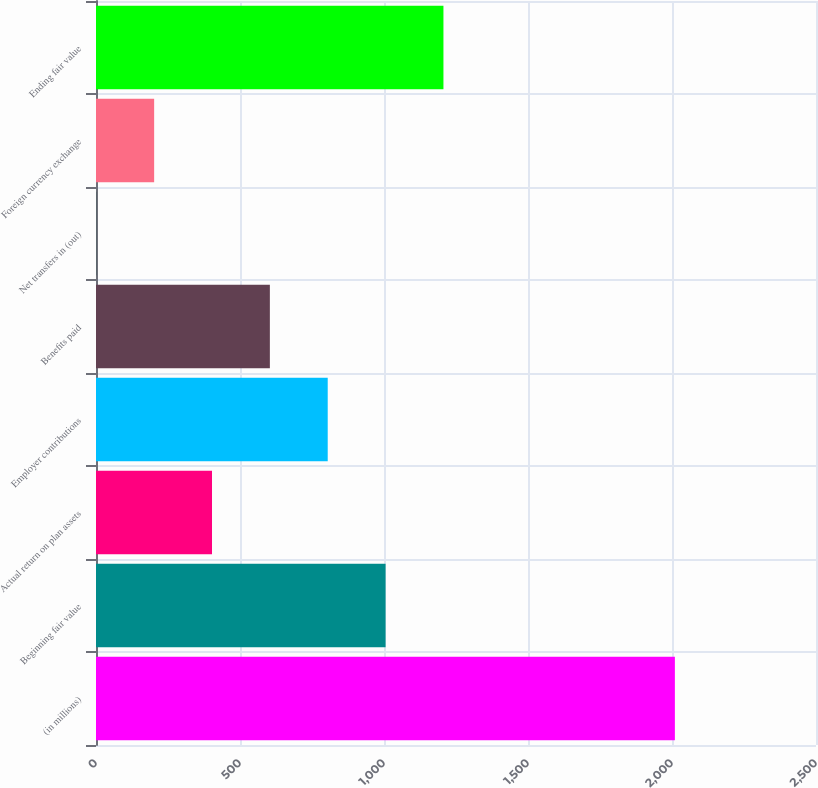Convert chart to OTSL. <chart><loc_0><loc_0><loc_500><loc_500><bar_chart><fcel>(in millions)<fcel>Beginning fair value<fcel>Actual return on plan assets<fcel>Employer contributions<fcel>Benefits paid<fcel>Net transfers in (out)<fcel>Foreign currency exchange<fcel>Ending fair value<nl><fcel>2010<fcel>1005.5<fcel>402.8<fcel>804.6<fcel>603.7<fcel>1<fcel>201.9<fcel>1206.4<nl></chart> 